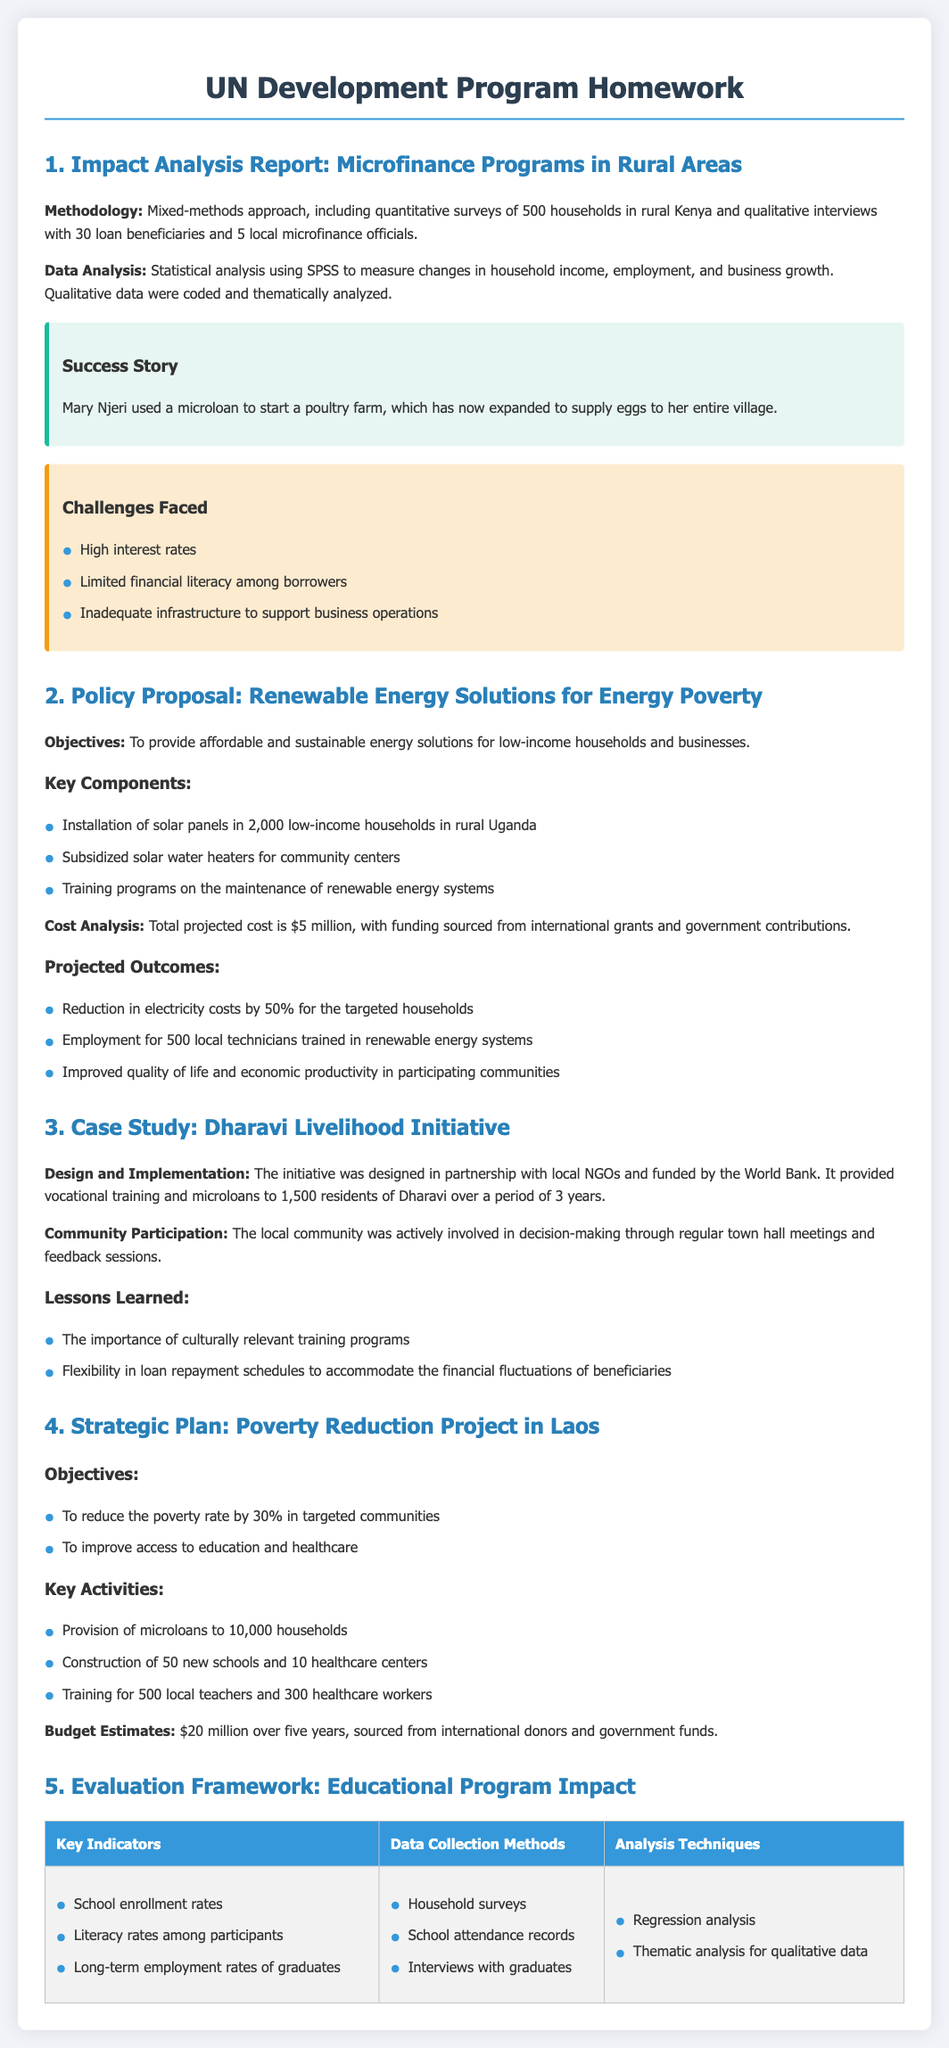What is the sample size of the households surveyed in the microfinance report? The sample size is a specific number mentioned in the methodology section of the report, which is 500 households.
Answer: 500 households What is the total projected cost for the renewable energy policy proposal? The total projected cost can be found in the cost analysis section of the policy proposal, which states it is $5 million.
Answer: $5 million Which community was involved in the case study? The community involved is specified in the title of the case study as well as in the design and implementation details.
Answer: Dharavi What percentage reduction in the poverty rate is targeted in the Laos strategic plan? The targeted poverty rate reduction is mentioned in the objectives section of the strategic plan, which states 30%.
Answer: 30% What method is used for data collection in the evaluation framework for the educational program? The data collection methods are listed in the evaluation framework table, highlighting household surveys as one of the methods.
Answer: Household surveys What challenge is listed regarding the microfinance programs? One of the challenges enumerated in the document is high interest rates, which are specifically mentioned under challenges faced.
Answer: High interest rates How many vocational training sessions were provided in the Dharavi initiative? The provided number of residents who received vocational training, indicating the scale of the initiative, is 1,500 residents.
Answer: 1,500 residents What is the budget estimate for the poverty reduction project in Laos? The budget estimates for the project over five years are directly stated in the strategic plan section, amounting to $20 million.
Answer: $20 million What key indicator measures literacy rates in the educational program evaluation framework? The key indicator related to literacy rates is detailed in the framework table, specifically identifying literacy rates among participants as an indicator.
Answer: Literacy rates among participants 